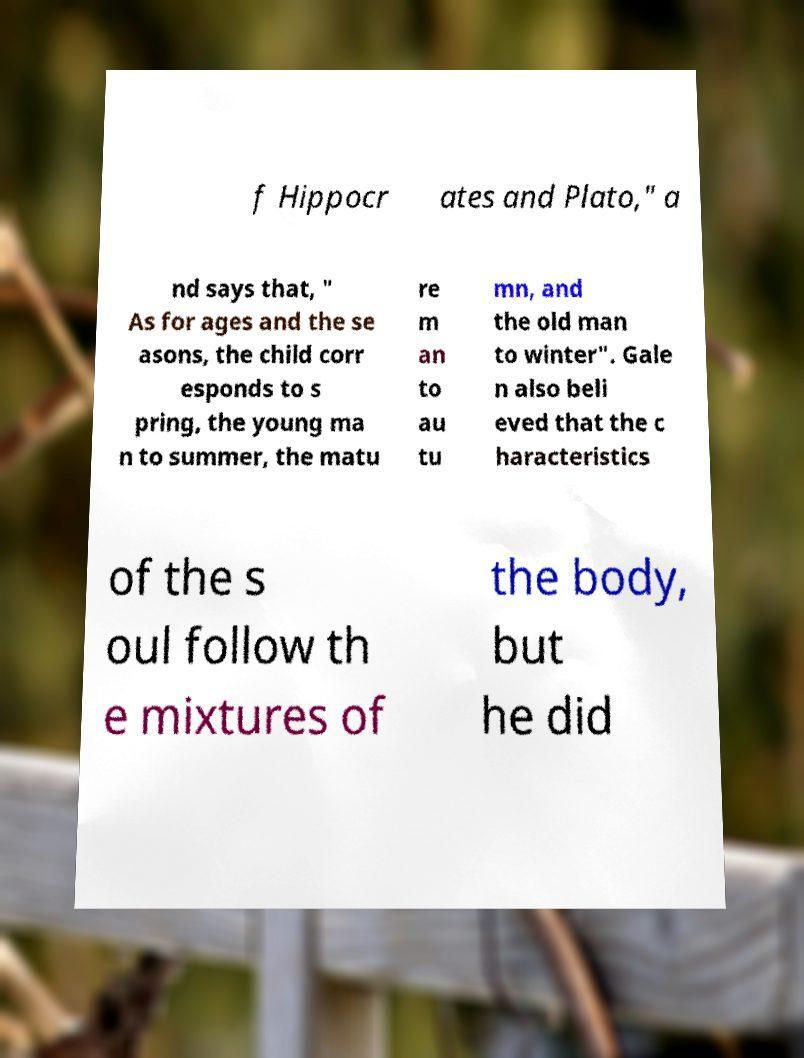Please identify and transcribe the text found in this image. f Hippocr ates and Plato," a nd says that, " As for ages and the se asons, the child corr esponds to s pring, the young ma n to summer, the matu re m an to au tu mn, and the old man to winter". Gale n also beli eved that the c haracteristics of the s oul follow th e mixtures of the body, but he did 